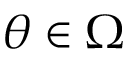Convert formula to latex. <formula><loc_0><loc_0><loc_500><loc_500>\theta \in \Omega</formula> 